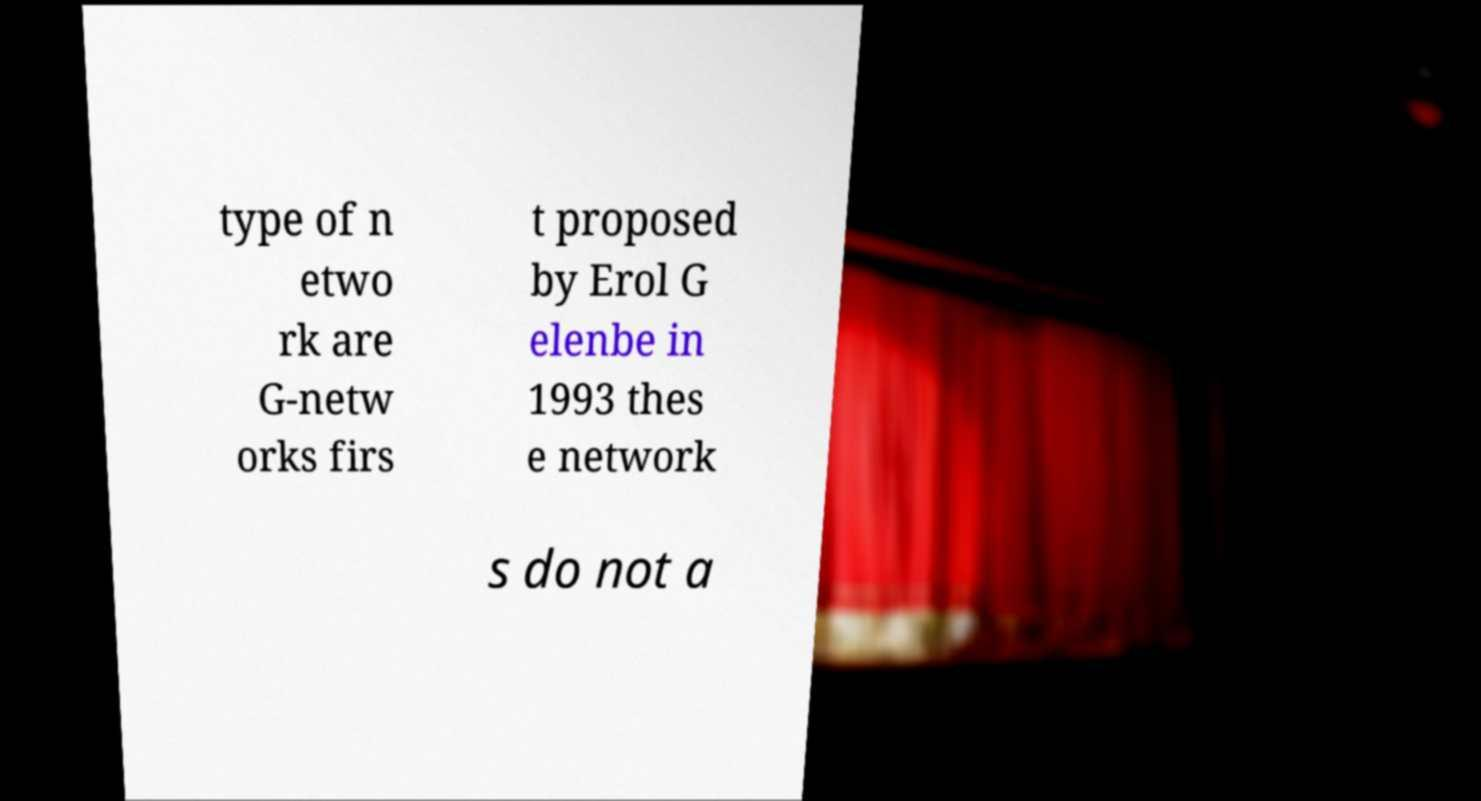For documentation purposes, I need the text within this image transcribed. Could you provide that? type of n etwo rk are G-netw orks firs t proposed by Erol G elenbe in 1993 thes e network s do not a 